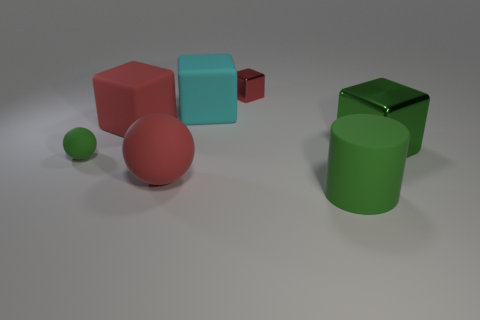Add 2 green spheres. How many objects exist? 9 Subtract all green blocks. How many blocks are left? 3 Subtract all big blocks. How many blocks are left? 1 Subtract 3 blocks. How many blocks are left? 1 Add 7 small green objects. How many small green objects exist? 8 Subtract 0 brown cylinders. How many objects are left? 7 Subtract all cubes. How many objects are left? 3 Subtract all red balls. Subtract all yellow cylinders. How many balls are left? 1 Subtract all blue cylinders. How many green spheres are left? 1 Subtract all large cyan things. Subtract all large red rubber objects. How many objects are left? 4 